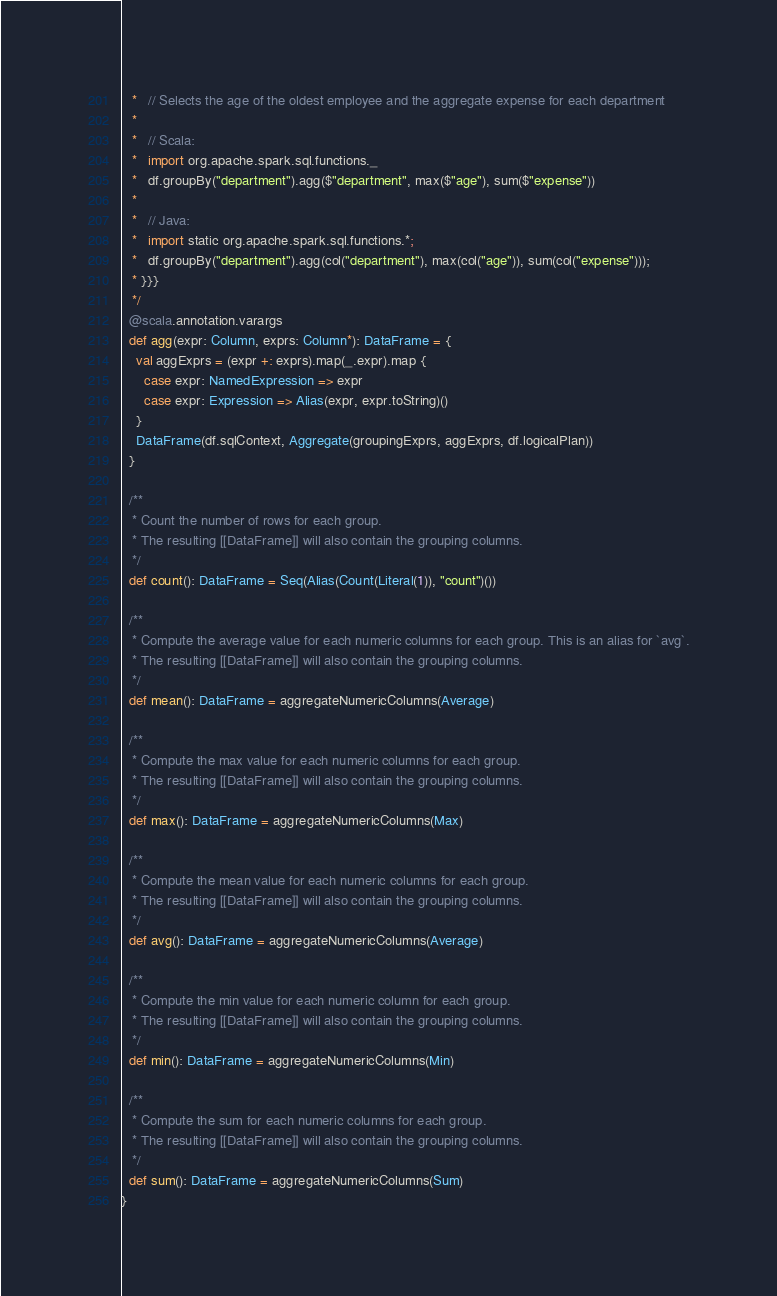<code> <loc_0><loc_0><loc_500><loc_500><_Scala_>   *   // Selects the age of the oldest employee and the aggregate expense for each department
   *
   *   // Scala:
   *   import org.apache.spark.sql.functions._
   *   df.groupBy("department").agg($"department", max($"age"), sum($"expense"))
   *
   *   // Java:
   *   import static org.apache.spark.sql.functions.*;
   *   df.groupBy("department").agg(col("department"), max(col("age")), sum(col("expense")));
   * }}}
   */
  @scala.annotation.varargs
  def agg(expr: Column, exprs: Column*): DataFrame = {
    val aggExprs = (expr +: exprs).map(_.expr).map {
      case expr: NamedExpression => expr
      case expr: Expression => Alias(expr, expr.toString)()
    }
    DataFrame(df.sqlContext, Aggregate(groupingExprs, aggExprs, df.logicalPlan))
  }

  /**
   * Count the number of rows for each group.
   * The resulting [[DataFrame]] will also contain the grouping columns.
   */
  def count(): DataFrame = Seq(Alias(Count(Literal(1)), "count")())

  /**
   * Compute the average value for each numeric columns for each group. This is an alias for `avg`.
   * The resulting [[DataFrame]] will also contain the grouping columns.
   */
  def mean(): DataFrame = aggregateNumericColumns(Average)

  /**
   * Compute the max value for each numeric columns for each group.
   * The resulting [[DataFrame]] will also contain the grouping columns.
   */
  def max(): DataFrame = aggregateNumericColumns(Max)

  /**
   * Compute the mean value for each numeric columns for each group.
   * The resulting [[DataFrame]] will also contain the grouping columns.
   */
  def avg(): DataFrame = aggregateNumericColumns(Average)

  /**
   * Compute the min value for each numeric column for each group.
   * The resulting [[DataFrame]] will also contain the grouping columns.
   */
  def min(): DataFrame = aggregateNumericColumns(Min)

  /**
   * Compute the sum for each numeric columns for each group.
   * The resulting [[DataFrame]] will also contain the grouping columns.
   */
  def sum(): DataFrame = aggregateNumericColumns(Sum)
}
</code> 